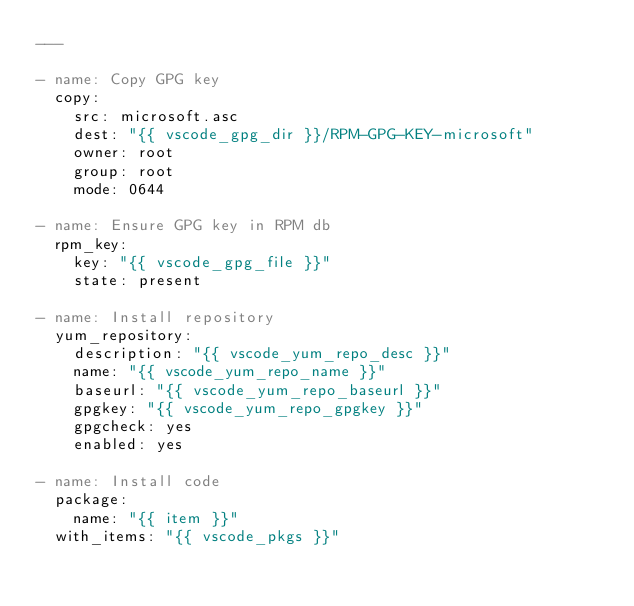<code> <loc_0><loc_0><loc_500><loc_500><_YAML_>---

- name: Copy GPG key
  copy:
    src: microsoft.asc
    dest: "{{ vscode_gpg_dir }}/RPM-GPG-KEY-microsoft"
    owner: root
    group: root
    mode: 0644

- name: Ensure GPG key in RPM db
  rpm_key:
    key: "{{ vscode_gpg_file }}"
    state: present

- name: Install repository
  yum_repository:
    description: "{{ vscode_yum_repo_desc }}"
    name: "{{ vscode_yum_repo_name }}"
    baseurl: "{{ vscode_yum_repo_baseurl }}"
    gpgkey: "{{ vscode_yum_repo_gpgkey }}"
    gpgcheck: yes
    enabled: yes

- name: Install code
  package:
    name: "{{ item }}"
  with_items: "{{ vscode_pkgs }}"
</code> 